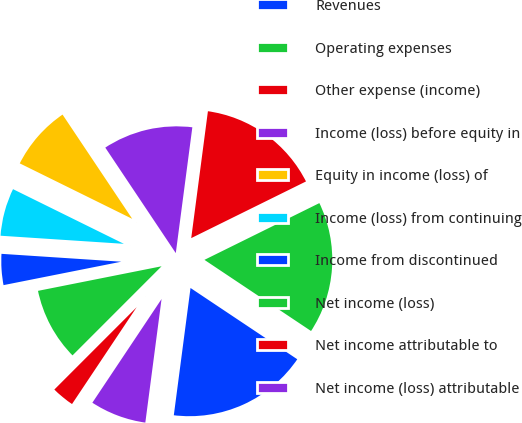Convert chart. <chart><loc_0><loc_0><loc_500><loc_500><pie_chart><fcel>Revenues<fcel>Operating expenses<fcel>Other expense (income)<fcel>Income (loss) before equity in<fcel>Equity in income (loss) of<fcel>Income (loss) from continuing<fcel>Income from discontinued<fcel>Net income (loss)<fcel>Net income attributable to<fcel>Net income (loss) attributable<nl><fcel>17.71%<fcel>16.67%<fcel>15.62%<fcel>11.46%<fcel>8.33%<fcel>6.25%<fcel>4.17%<fcel>9.38%<fcel>3.13%<fcel>7.29%<nl></chart> 